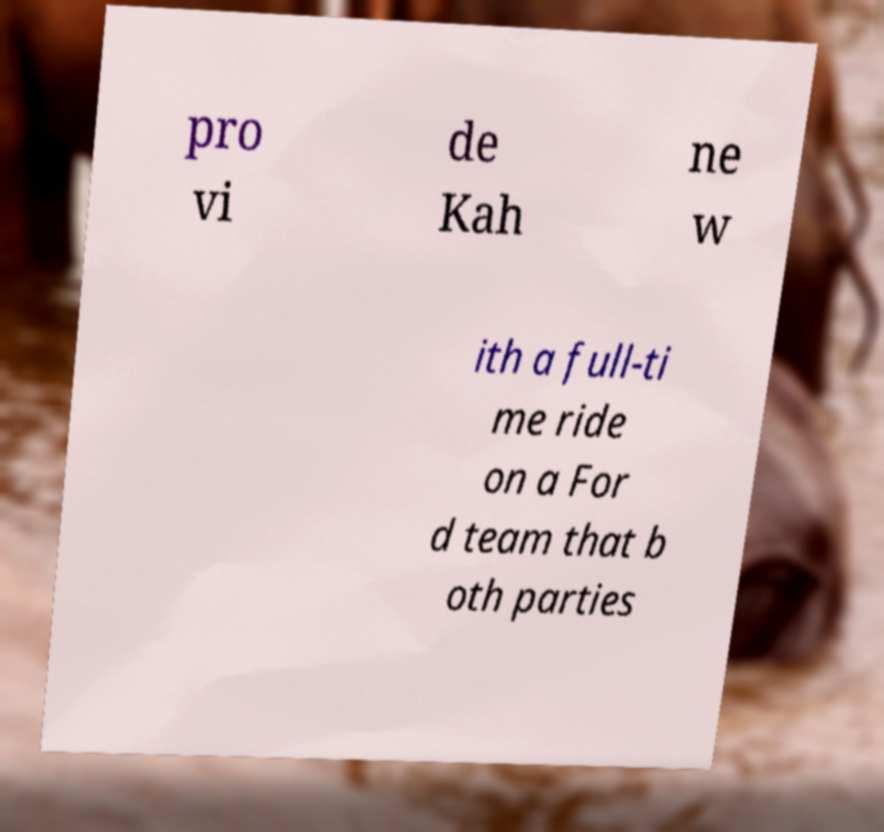I need the written content from this picture converted into text. Can you do that? pro vi de Kah ne w ith a full-ti me ride on a For d team that b oth parties 